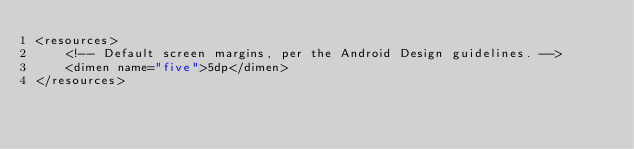Convert code to text. <code><loc_0><loc_0><loc_500><loc_500><_XML_><resources>
    <!-- Default screen margins, per the Android Design guidelines. -->
    <dimen name="five">5dp</dimen>
</resources>
</code> 